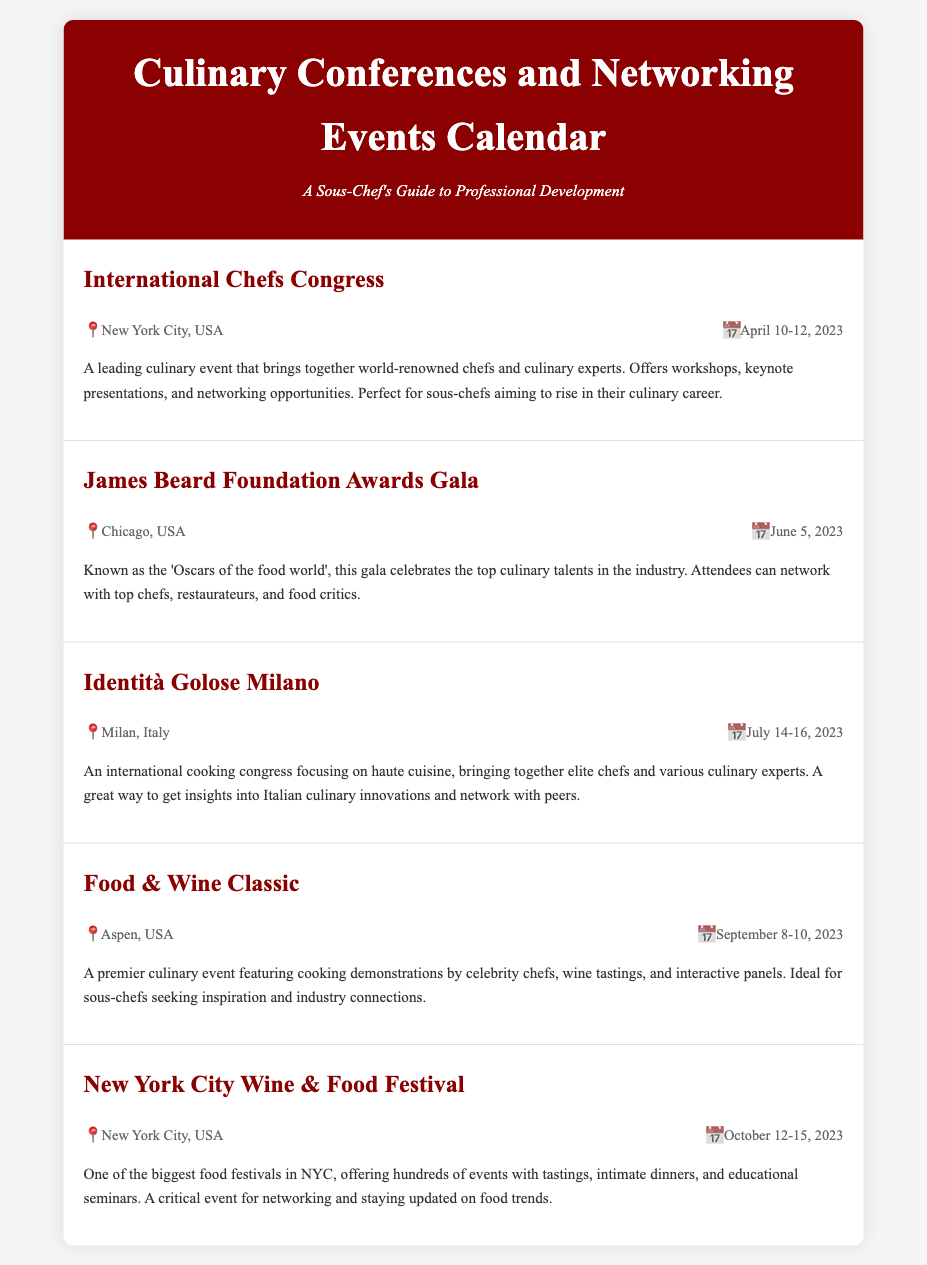What is the location of the International Chefs Congress? The International Chefs Congress is held in New York City, USA.
Answer: New York City, USA When is the James Beard Foundation Awards Gala? The James Beard Foundation Awards Gala takes place on June 5, 2023.
Answer: June 5, 2023 What type of event is Identità Golose Milano? Identità Golose Milano is an international cooking congress focusing on haute cuisine.
Answer: International cooking congress Which event occurs last in the calendar? The last event in the calendar is the New York City Wine & Food Festival.
Answer: New York City Wine & Food Festival How long is the Food & Wine Classic? The Food & Wine Classic spans three days from September 8 to September 10, 2023.
Answer: Three days What is a major benefit of attending the New York City Wine & Food Festival? A major benefit of attending the New York City Wine & Food Festival is networking and staying updated on food trends.
Answer: Networking and staying updated What is the primary focus of the International Chefs Congress? The primary focus of the International Chefs Congress is workshops, keynote presentations, and networking opportunities for culinary professionals.
Answer: Workshops, keynote presentations, and networking opportunities Which city hosts the Food & Wine Classic? The Food & Wine Classic is hosted in Aspen, USA.
Answer: Aspen, USA 